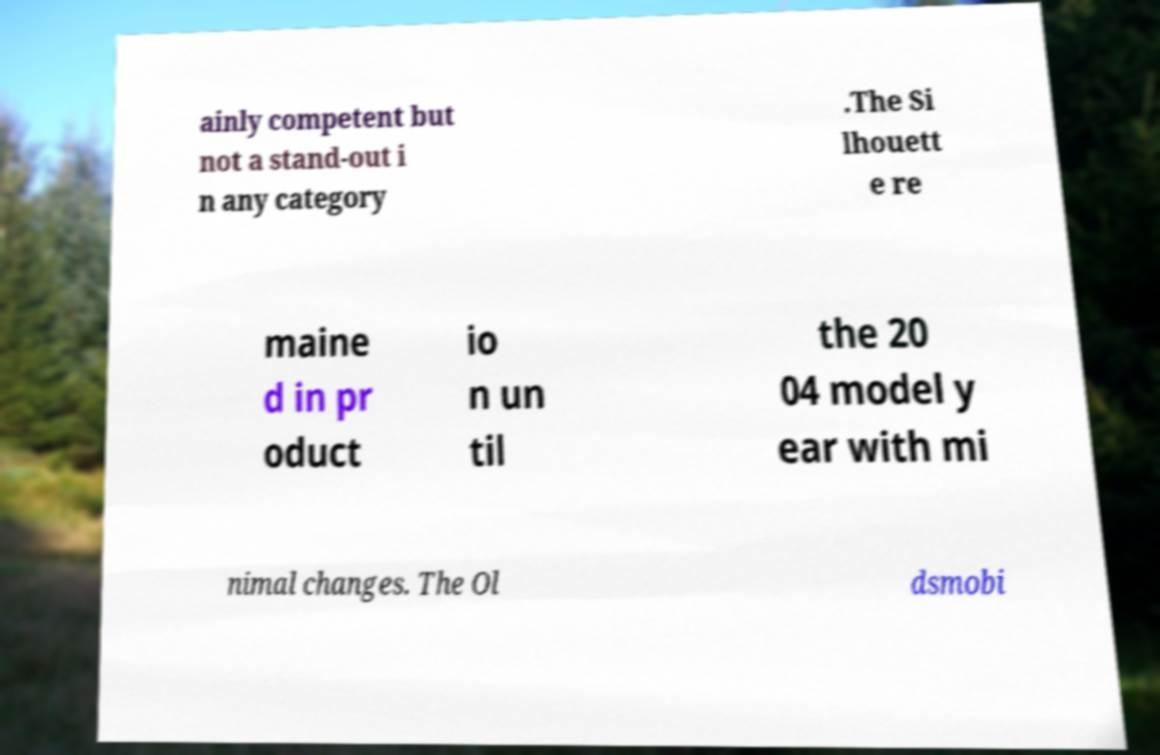Could you extract and type out the text from this image? ainly competent but not a stand-out i n any category .The Si lhouett e re maine d in pr oduct io n un til the 20 04 model y ear with mi nimal changes. The Ol dsmobi 